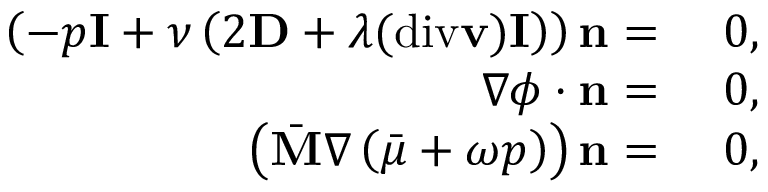Convert formula to latex. <formula><loc_0><loc_0><loc_500><loc_500>\begin{array} { r l } { \left ( - p I + \nu \left ( 2 D + \lambda ( d i v v ) I \right ) \right ) n = } & { 0 , } \\ { \nabla \phi \cdot n = } & { 0 , } \\ { \left ( \bar { M } \nabla \left ( \bar { \mu } + \omega p \right ) \right ) n = } & { 0 , } \end{array}</formula> 